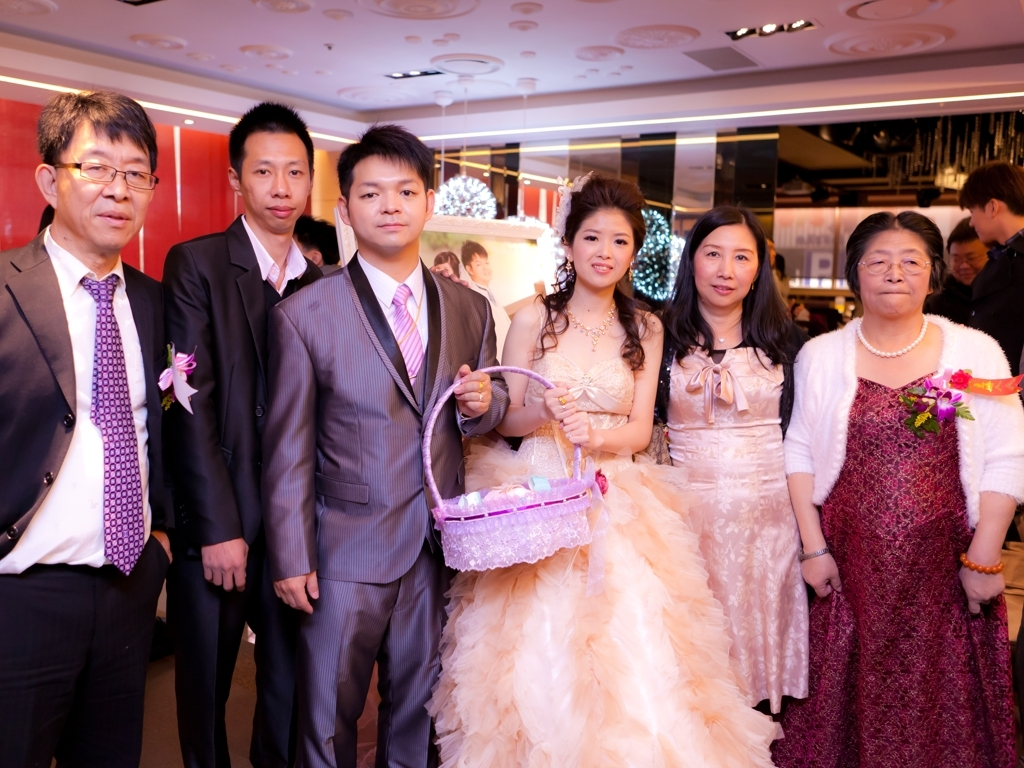Is the image quality good? The image appears to be of decent quality, with good lighting and clear details captured. Colors are vivid, and the subjects are in focus, indicating the use of a capable camera. There is minimal noise or blur, suggesting a steady hand or possibly a tripod was used. However, it doesn't seem to be of an exceptionally high resolution or professional quality, hence it's better than average but not excellent. 